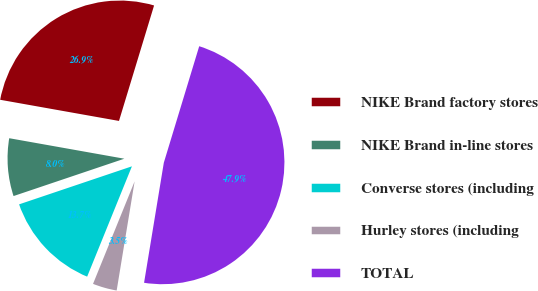Convert chart. <chart><loc_0><loc_0><loc_500><loc_500><pie_chart><fcel>NIKE Brand factory stores<fcel>NIKE Brand in-line stores<fcel>Converse stores (including<fcel>Hurley stores (including<fcel>TOTAL<nl><fcel>26.89%<fcel>7.98%<fcel>13.69%<fcel>3.54%<fcel>47.9%<nl></chart> 